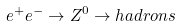Convert formula to latex. <formula><loc_0><loc_0><loc_500><loc_500>e ^ { + } e ^ { - } \rightarrow Z ^ { 0 } \rightarrow h a d r o n s</formula> 